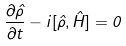Convert formula to latex. <formula><loc_0><loc_0><loc_500><loc_500>\frac { \partial \hat { \rho } } { \partial t } - i [ \hat { \rho } , \hat { H } ] = 0</formula> 